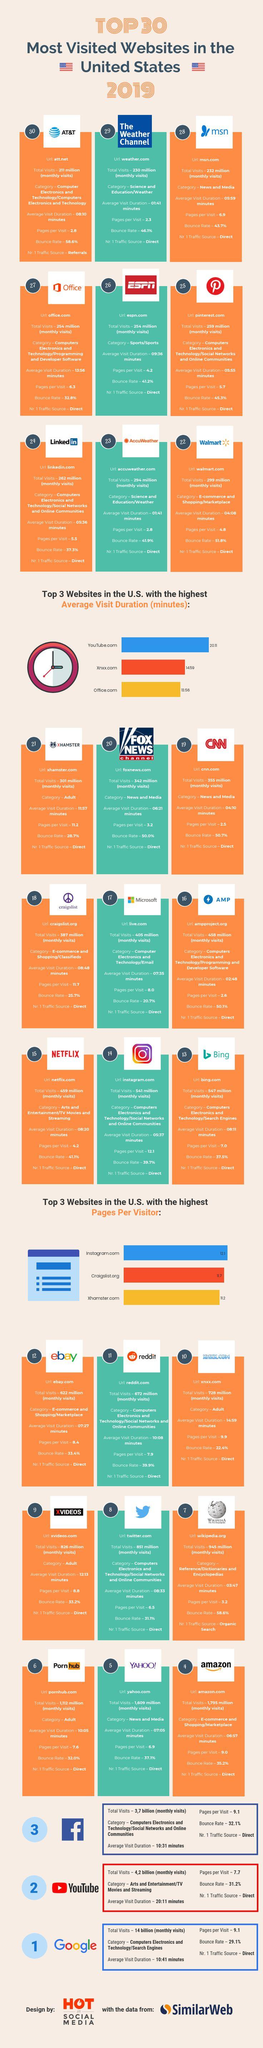Draw attention to some important aspects in this diagram. According to the data, Xnxx.com has the second highest average visit duration among the three websites being compared: Xnxx.com, Office.com, and YouTube.com. The website that appears in the 14th position is Instagram. Out of the websites that have traffic sources, organic search is one of them. The number of total monthly visits for Google and YouTube is 9.8 billion. Facebook has a higher bounce rate than YouTube and Google. 